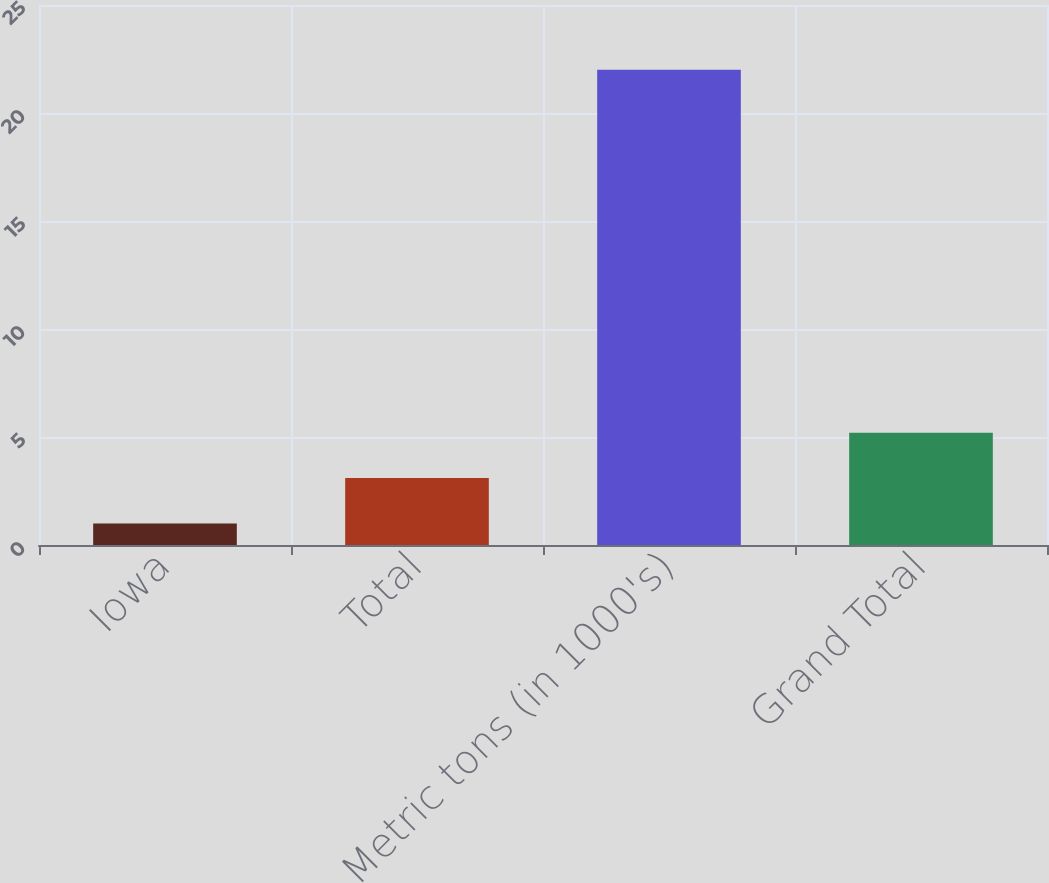Convert chart to OTSL. <chart><loc_0><loc_0><loc_500><loc_500><bar_chart><fcel>Iowa<fcel>Total<fcel>Metric tons (in 1000's)<fcel>Grand Total<nl><fcel>1<fcel>3.1<fcel>22<fcel>5.2<nl></chart> 